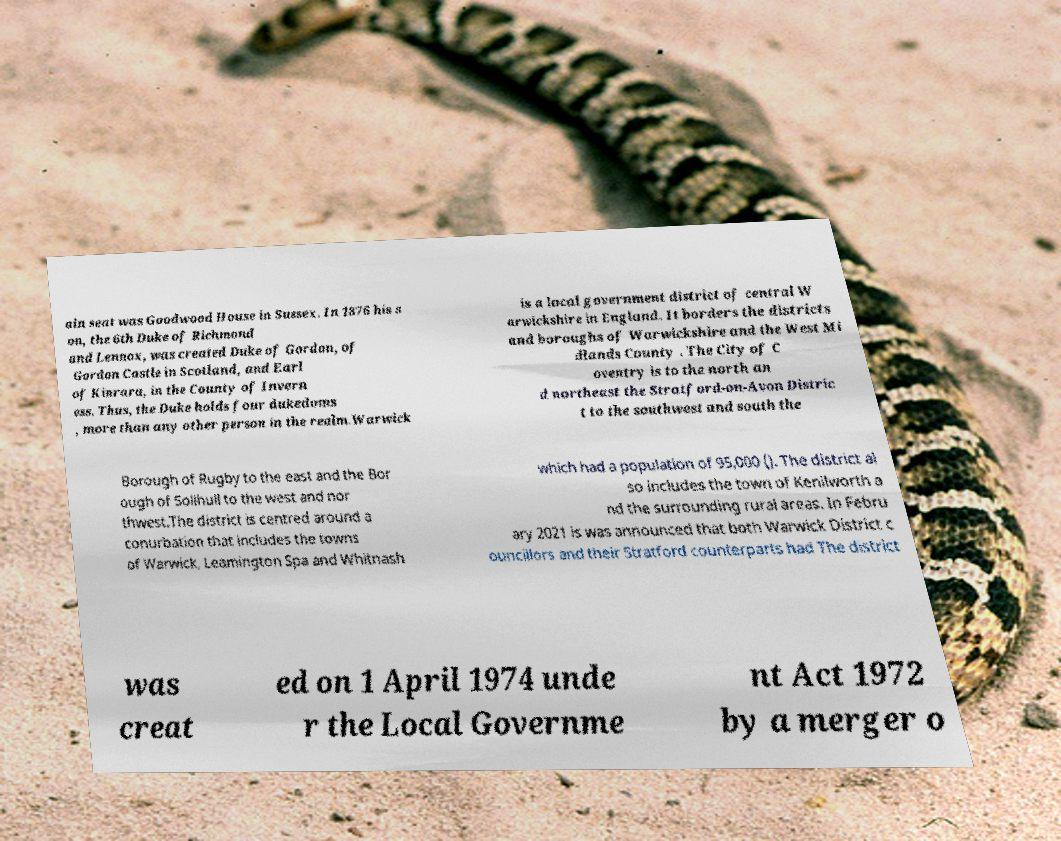Can you accurately transcribe the text from the provided image for me? ain seat was Goodwood House in Sussex. In 1876 his s on, the 6th Duke of Richmond and Lennox, was created Duke of Gordon, of Gordon Castle in Scotland, and Earl of Kinrara, in the County of Invern ess. Thus, the Duke holds four dukedoms , more than any other person in the realm.Warwick is a local government district of central W arwickshire in England. It borders the districts and boroughs of Warwickshire and the West Mi dlands County . The City of C oventry is to the north an d northeast the Stratford-on-Avon Distric t to the southwest and south the Borough of Rugby to the east and the Bor ough of Solihull to the west and nor thwest.The district is centred around a conurbation that includes the towns of Warwick, Leamington Spa and Whitnash which had a population of 95,000 (). The district al so includes the town of Kenilworth a nd the surrounding rural areas. In Febru ary 2021 is was announced that both Warwick District c ouncillors and their Stratford counterparts had The district was creat ed on 1 April 1974 unde r the Local Governme nt Act 1972 by a merger o 